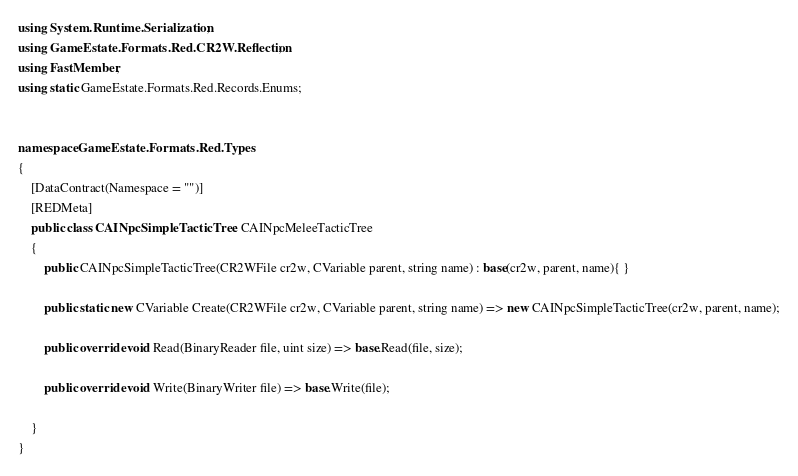<code> <loc_0><loc_0><loc_500><loc_500><_C#_>using System.Runtime.Serialization;
using GameEstate.Formats.Red.CR2W.Reflection;
using FastMember;
using static GameEstate.Formats.Red.Records.Enums;


namespace GameEstate.Formats.Red.Types
{
	[DataContract(Namespace = "")]
	[REDMeta]
	public class CAINpcSimpleTacticTree : CAINpcMeleeTacticTree
	{
		public CAINpcSimpleTacticTree(CR2WFile cr2w, CVariable parent, string name) : base(cr2w, parent, name){ }

		public static new CVariable Create(CR2WFile cr2w, CVariable parent, string name) => new CAINpcSimpleTacticTree(cr2w, parent, name);

		public override void Read(BinaryReader file, uint size) => base.Read(file, size);

		public override void Write(BinaryWriter file) => base.Write(file);

	}
}</code> 